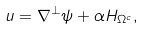<formula> <loc_0><loc_0><loc_500><loc_500>u = \nabla ^ { \perp } \psi + \alpha H _ { \Omega ^ { c } } ,</formula> 